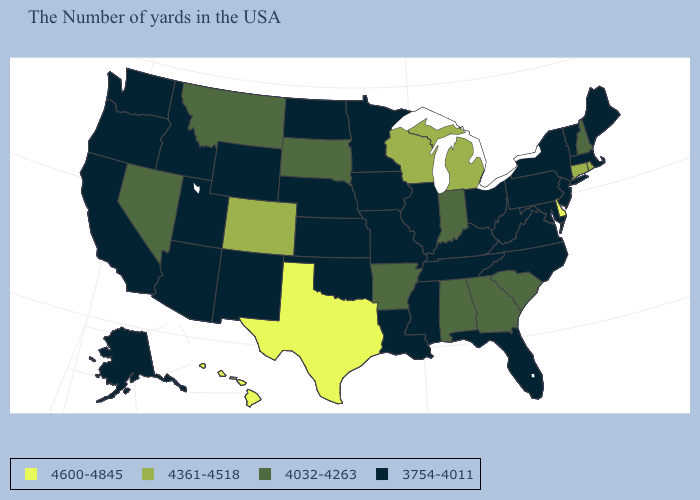How many symbols are there in the legend?
Give a very brief answer. 4. What is the lowest value in states that border North Carolina?
Quick response, please. 3754-4011. What is the lowest value in states that border Arkansas?
Keep it brief. 3754-4011. How many symbols are there in the legend?
Be succinct. 4. What is the value of Oklahoma?
Quick response, please. 3754-4011. Does Montana have the highest value in the West?
Write a very short answer. No. Among the states that border New York , does Connecticut have the highest value?
Be succinct. Yes. Which states hav the highest value in the West?
Write a very short answer. Hawaii. Name the states that have a value in the range 3754-4011?
Give a very brief answer. Maine, Massachusetts, Vermont, New York, New Jersey, Maryland, Pennsylvania, Virginia, North Carolina, West Virginia, Ohio, Florida, Kentucky, Tennessee, Illinois, Mississippi, Louisiana, Missouri, Minnesota, Iowa, Kansas, Nebraska, Oklahoma, North Dakota, Wyoming, New Mexico, Utah, Arizona, Idaho, California, Washington, Oregon, Alaska. Which states have the lowest value in the Northeast?
Answer briefly. Maine, Massachusetts, Vermont, New York, New Jersey, Pennsylvania. What is the highest value in the USA?
Give a very brief answer. 4600-4845. Does Hawaii have the highest value in the West?
Be succinct. Yes. Does the first symbol in the legend represent the smallest category?
Give a very brief answer. No. Name the states that have a value in the range 4600-4845?
Concise answer only. Delaware, Texas, Hawaii. 